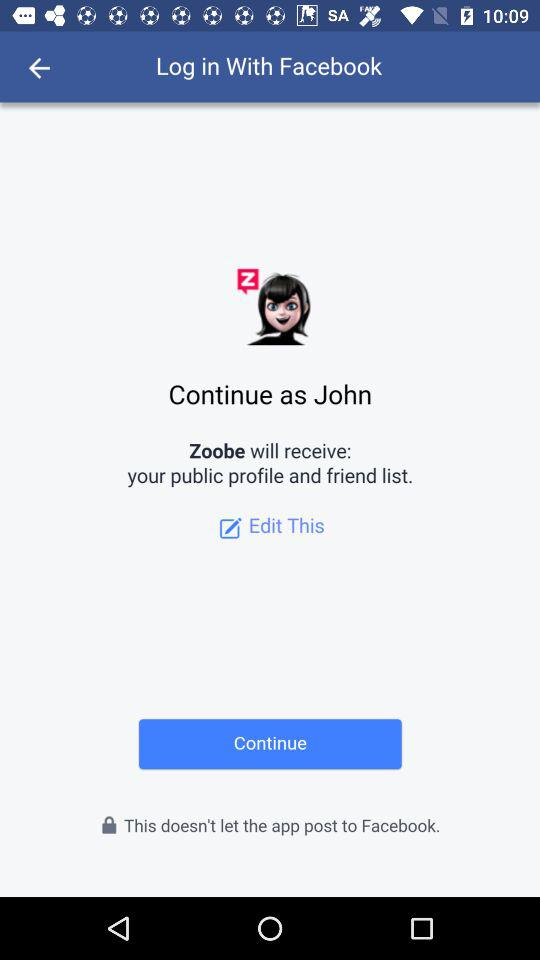What is the name of the user? The name of the user is John. 